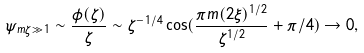Convert formula to latex. <formula><loc_0><loc_0><loc_500><loc_500>\psi _ { m \zeta \gg 1 } \sim \frac { \phi ( \zeta ) } { \zeta } \sim \zeta ^ { - 1 / 4 } \cos ( \frac { \pi m ( 2 \xi ) ^ { 1 / 2 } } { \zeta ^ { 1 / 2 } } + \pi / 4 ) \rightarrow 0 ,</formula> 